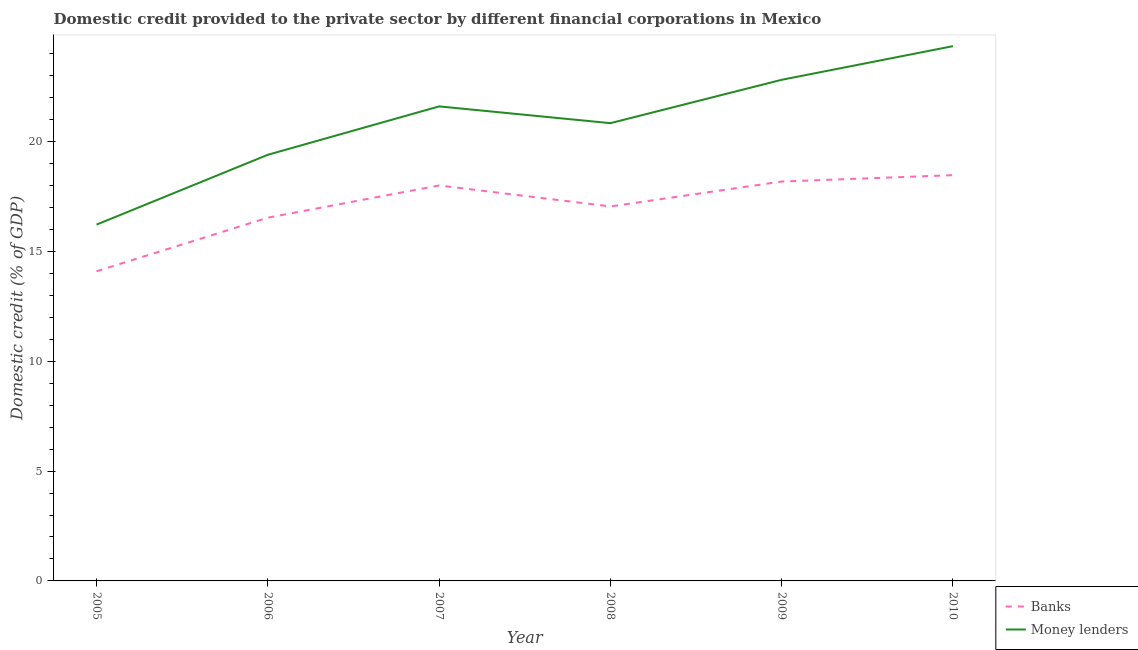Is the number of lines equal to the number of legend labels?
Keep it short and to the point. Yes. What is the domestic credit provided by money lenders in 2010?
Provide a short and direct response. 24.34. Across all years, what is the maximum domestic credit provided by money lenders?
Provide a short and direct response. 24.34. Across all years, what is the minimum domestic credit provided by money lenders?
Your answer should be very brief. 16.22. What is the total domestic credit provided by banks in the graph?
Keep it short and to the point. 102.33. What is the difference between the domestic credit provided by money lenders in 2005 and that in 2007?
Provide a short and direct response. -5.38. What is the difference between the domestic credit provided by money lenders in 2009 and the domestic credit provided by banks in 2008?
Offer a terse response. 5.77. What is the average domestic credit provided by banks per year?
Your answer should be compact. 17.05. In the year 2005, what is the difference between the domestic credit provided by banks and domestic credit provided by money lenders?
Give a very brief answer. -2.12. What is the ratio of the domestic credit provided by banks in 2008 to that in 2009?
Give a very brief answer. 0.94. What is the difference between the highest and the second highest domestic credit provided by banks?
Offer a terse response. 0.29. What is the difference between the highest and the lowest domestic credit provided by money lenders?
Offer a very short reply. 8.12. Is the domestic credit provided by banks strictly less than the domestic credit provided by money lenders over the years?
Provide a short and direct response. Yes. How many lines are there?
Offer a very short reply. 2. How many years are there in the graph?
Give a very brief answer. 6. Does the graph contain grids?
Provide a short and direct response. No. Where does the legend appear in the graph?
Keep it short and to the point. Bottom right. How are the legend labels stacked?
Provide a succinct answer. Vertical. What is the title of the graph?
Provide a succinct answer. Domestic credit provided to the private sector by different financial corporations in Mexico. Does "US$" appear as one of the legend labels in the graph?
Provide a succinct answer. No. What is the label or title of the Y-axis?
Ensure brevity in your answer.  Domestic credit (% of GDP). What is the Domestic credit (% of GDP) of Banks in 2005?
Your answer should be very brief. 14.1. What is the Domestic credit (% of GDP) in Money lenders in 2005?
Offer a terse response. 16.22. What is the Domestic credit (% of GDP) in Banks in 2006?
Give a very brief answer. 16.54. What is the Domestic credit (% of GDP) of Money lenders in 2006?
Make the answer very short. 19.4. What is the Domestic credit (% of GDP) in Banks in 2007?
Your response must be concise. 18. What is the Domestic credit (% of GDP) in Money lenders in 2007?
Offer a terse response. 21.6. What is the Domestic credit (% of GDP) of Banks in 2008?
Keep it short and to the point. 17.05. What is the Domestic credit (% of GDP) of Money lenders in 2008?
Your answer should be compact. 20.84. What is the Domestic credit (% of GDP) in Banks in 2009?
Make the answer very short. 18.18. What is the Domestic credit (% of GDP) of Money lenders in 2009?
Offer a terse response. 22.81. What is the Domestic credit (% of GDP) of Banks in 2010?
Give a very brief answer. 18.47. What is the Domestic credit (% of GDP) of Money lenders in 2010?
Give a very brief answer. 24.34. Across all years, what is the maximum Domestic credit (% of GDP) of Banks?
Provide a succinct answer. 18.47. Across all years, what is the maximum Domestic credit (% of GDP) of Money lenders?
Offer a terse response. 24.34. Across all years, what is the minimum Domestic credit (% of GDP) of Banks?
Your answer should be very brief. 14.1. Across all years, what is the minimum Domestic credit (% of GDP) of Money lenders?
Your response must be concise. 16.22. What is the total Domestic credit (% of GDP) in Banks in the graph?
Ensure brevity in your answer.  102.33. What is the total Domestic credit (% of GDP) in Money lenders in the graph?
Provide a succinct answer. 125.21. What is the difference between the Domestic credit (% of GDP) in Banks in 2005 and that in 2006?
Your answer should be very brief. -2.44. What is the difference between the Domestic credit (% of GDP) in Money lenders in 2005 and that in 2006?
Keep it short and to the point. -3.18. What is the difference between the Domestic credit (% of GDP) of Banks in 2005 and that in 2007?
Your response must be concise. -3.91. What is the difference between the Domestic credit (% of GDP) of Money lenders in 2005 and that in 2007?
Your answer should be compact. -5.38. What is the difference between the Domestic credit (% of GDP) in Banks in 2005 and that in 2008?
Offer a very short reply. -2.95. What is the difference between the Domestic credit (% of GDP) in Money lenders in 2005 and that in 2008?
Provide a succinct answer. -4.62. What is the difference between the Domestic credit (% of GDP) in Banks in 2005 and that in 2009?
Ensure brevity in your answer.  -4.08. What is the difference between the Domestic credit (% of GDP) in Money lenders in 2005 and that in 2009?
Your answer should be compact. -6.59. What is the difference between the Domestic credit (% of GDP) of Banks in 2005 and that in 2010?
Offer a terse response. -4.38. What is the difference between the Domestic credit (% of GDP) of Money lenders in 2005 and that in 2010?
Provide a succinct answer. -8.12. What is the difference between the Domestic credit (% of GDP) of Banks in 2006 and that in 2007?
Offer a terse response. -1.47. What is the difference between the Domestic credit (% of GDP) in Money lenders in 2006 and that in 2007?
Ensure brevity in your answer.  -2.2. What is the difference between the Domestic credit (% of GDP) in Banks in 2006 and that in 2008?
Keep it short and to the point. -0.51. What is the difference between the Domestic credit (% of GDP) in Money lenders in 2006 and that in 2008?
Make the answer very short. -1.44. What is the difference between the Domestic credit (% of GDP) in Banks in 2006 and that in 2009?
Offer a very short reply. -1.64. What is the difference between the Domestic credit (% of GDP) in Money lenders in 2006 and that in 2009?
Your answer should be compact. -3.41. What is the difference between the Domestic credit (% of GDP) of Banks in 2006 and that in 2010?
Provide a short and direct response. -1.93. What is the difference between the Domestic credit (% of GDP) of Money lenders in 2006 and that in 2010?
Give a very brief answer. -4.95. What is the difference between the Domestic credit (% of GDP) in Banks in 2007 and that in 2008?
Make the answer very short. 0.96. What is the difference between the Domestic credit (% of GDP) of Money lenders in 2007 and that in 2008?
Ensure brevity in your answer.  0.76. What is the difference between the Domestic credit (% of GDP) of Banks in 2007 and that in 2009?
Make the answer very short. -0.18. What is the difference between the Domestic credit (% of GDP) of Money lenders in 2007 and that in 2009?
Offer a very short reply. -1.21. What is the difference between the Domestic credit (% of GDP) of Banks in 2007 and that in 2010?
Provide a short and direct response. -0.47. What is the difference between the Domestic credit (% of GDP) of Money lenders in 2007 and that in 2010?
Offer a terse response. -2.74. What is the difference between the Domestic credit (% of GDP) in Banks in 2008 and that in 2009?
Keep it short and to the point. -1.13. What is the difference between the Domestic credit (% of GDP) in Money lenders in 2008 and that in 2009?
Your answer should be compact. -1.97. What is the difference between the Domestic credit (% of GDP) of Banks in 2008 and that in 2010?
Provide a succinct answer. -1.42. What is the difference between the Domestic credit (% of GDP) of Money lenders in 2008 and that in 2010?
Make the answer very short. -3.51. What is the difference between the Domestic credit (% of GDP) of Banks in 2009 and that in 2010?
Your answer should be very brief. -0.29. What is the difference between the Domestic credit (% of GDP) in Money lenders in 2009 and that in 2010?
Keep it short and to the point. -1.53. What is the difference between the Domestic credit (% of GDP) of Banks in 2005 and the Domestic credit (% of GDP) of Money lenders in 2006?
Provide a short and direct response. -5.3. What is the difference between the Domestic credit (% of GDP) in Banks in 2005 and the Domestic credit (% of GDP) in Money lenders in 2007?
Offer a very short reply. -7.5. What is the difference between the Domestic credit (% of GDP) in Banks in 2005 and the Domestic credit (% of GDP) in Money lenders in 2008?
Your response must be concise. -6.74. What is the difference between the Domestic credit (% of GDP) in Banks in 2005 and the Domestic credit (% of GDP) in Money lenders in 2009?
Make the answer very short. -8.72. What is the difference between the Domestic credit (% of GDP) of Banks in 2005 and the Domestic credit (% of GDP) of Money lenders in 2010?
Offer a very short reply. -10.25. What is the difference between the Domestic credit (% of GDP) of Banks in 2006 and the Domestic credit (% of GDP) of Money lenders in 2007?
Make the answer very short. -5.06. What is the difference between the Domestic credit (% of GDP) of Banks in 2006 and the Domestic credit (% of GDP) of Money lenders in 2008?
Ensure brevity in your answer.  -4.3. What is the difference between the Domestic credit (% of GDP) of Banks in 2006 and the Domestic credit (% of GDP) of Money lenders in 2009?
Keep it short and to the point. -6.28. What is the difference between the Domestic credit (% of GDP) of Banks in 2006 and the Domestic credit (% of GDP) of Money lenders in 2010?
Give a very brief answer. -7.81. What is the difference between the Domestic credit (% of GDP) of Banks in 2007 and the Domestic credit (% of GDP) of Money lenders in 2008?
Make the answer very short. -2.83. What is the difference between the Domestic credit (% of GDP) of Banks in 2007 and the Domestic credit (% of GDP) of Money lenders in 2009?
Offer a very short reply. -4.81. What is the difference between the Domestic credit (% of GDP) in Banks in 2007 and the Domestic credit (% of GDP) in Money lenders in 2010?
Ensure brevity in your answer.  -6.34. What is the difference between the Domestic credit (% of GDP) in Banks in 2008 and the Domestic credit (% of GDP) in Money lenders in 2009?
Your answer should be very brief. -5.77. What is the difference between the Domestic credit (% of GDP) in Banks in 2008 and the Domestic credit (% of GDP) in Money lenders in 2010?
Provide a short and direct response. -7.3. What is the difference between the Domestic credit (% of GDP) of Banks in 2009 and the Domestic credit (% of GDP) of Money lenders in 2010?
Provide a short and direct response. -6.16. What is the average Domestic credit (% of GDP) in Banks per year?
Offer a terse response. 17.05. What is the average Domestic credit (% of GDP) in Money lenders per year?
Offer a terse response. 20.87. In the year 2005, what is the difference between the Domestic credit (% of GDP) of Banks and Domestic credit (% of GDP) of Money lenders?
Ensure brevity in your answer.  -2.12. In the year 2006, what is the difference between the Domestic credit (% of GDP) in Banks and Domestic credit (% of GDP) in Money lenders?
Your answer should be compact. -2.86. In the year 2007, what is the difference between the Domestic credit (% of GDP) in Banks and Domestic credit (% of GDP) in Money lenders?
Ensure brevity in your answer.  -3.6. In the year 2008, what is the difference between the Domestic credit (% of GDP) of Banks and Domestic credit (% of GDP) of Money lenders?
Give a very brief answer. -3.79. In the year 2009, what is the difference between the Domestic credit (% of GDP) of Banks and Domestic credit (% of GDP) of Money lenders?
Your response must be concise. -4.63. In the year 2010, what is the difference between the Domestic credit (% of GDP) of Banks and Domestic credit (% of GDP) of Money lenders?
Your response must be concise. -5.87. What is the ratio of the Domestic credit (% of GDP) of Banks in 2005 to that in 2006?
Give a very brief answer. 0.85. What is the ratio of the Domestic credit (% of GDP) in Money lenders in 2005 to that in 2006?
Your answer should be very brief. 0.84. What is the ratio of the Domestic credit (% of GDP) of Banks in 2005 to that in 2007?
Keep it short and to the point. 0.78. What is the ratio of the Domestic credit (% of GDP) in Money lenders in 2005 to that in 2007?
Provide a short and direct response. 0.75. What is the ratio of the Domestic credit (% of GDP) in Banks in 2005 to that in 2008?
Your answer should be very brief. 0.83. What is the ratio of the Domestic credit (% of GDP) of Money lenders in 2005 to that in 2008?
Keep it short and to the point. 0.78. What is the ratio of the Domestic credit (% of GDP) in Banks in 2005 to that in 2009?
Your answer should be compact. 0.78. What is the ratio of the Domestic credit (% of GDP) in Money lenders in 2005 to that in 2009?
Ensure brevity in your answer.  0.71. What is the ratio of the Domestic credit (% of GDP) in Banks in 2005 to that in 2010?
Ensure brevity in your answer.  0.76. What is the ratio of the Domestic credit (% of GDP) of Money lenders in 2005 to that in 2010?
Your response must be concise. 0.67. What is the ratio of the Domestic credit (% of GDP) in Banks in 2006 to that in 2007?
Your response must be concise. 0.92. What is the ratio of the Domestic credit (% of GDP) of Money lenders in 2006 to that in 2007?
Make the answer very short. 0.9. What is the ratio of the Domestic credit (% of GDP) of Banks in 2006 to that in 2008?
Ensure brevity in your answer.  0.97. What is the ratio of the Domestic credit (% of GDP) in Money lenders in 2006 to that in 2008?
Offer a terse response. 0.93. What is the ratio of the Domestic credit (% of GDP) of Banks in 2006 to that in 2009?
Provide a succinct answer. 0.91. What is the ratio of the Domestic credit (% of GDP) of Money lenders in 2006 to that in 2009?
Keep it short and to the point. 0.85. What is the ratio of the Domestic credit (% of GDP) of Banks in 2006 to that in 2010?
Make the answer very short. 0.9. What is the ratio of the Domestic credit (% of GDP) in Money lenders in 2006 to that in 2010?
Offer a very short reply. 0.8. What is the ratio of the Domestic credit (% of GDP) of Banks in 2007 to that in 2008?
Keep it short and to the point. 1.06. What is the ratio of the Domestic credit (% of GDP) in Money lenders in 2007 to that in 2008?
Make the answer very short. 1.04. What is the ratio of the Domestic credit (% of GDP) of Banks in 2007 to that in 2009?
Your response must be concise. 0.99. What is the ratio of the Domestic credit (% of GDP) of Money lenders in 2007 to that in 2009?
Keep it short and to the point. 0.95. What is the ratio of the Domestic credit (% of GDP) in Banks in 2007 to that in 2010?
Offer a terse response. 0.97. What is the ratio of the Domestic credit (% of GDP) in Money lenders in 2007 to that in 2010?
Keep it short and to the point. 0.89. What is the ratio of the Domestic credit (% of GDP) of Banks in 2008 to that in 2009?
Your answer should be compact. 0.94. What is the ratio of the Domestic credit (% of GDP) in Money lenders in 2008 to that in 2009?
Provide a succinct answer. 0.91. What is the ratio of the Domestic credit (% of GDP) of Banks in 2008 to that in 2010?
Your response must be concise. 0.92. What is the ratio of the Domestic credit (% of GDP) in Money lenders in 2008 to that in 2010?
Offer a terse response. 0.86. What is the ratio of the Domestic credit (% of GDP) of Banks in 2009 to that in 2010?
Keep it short and to the point. 0.98. What is the ratio of the Domestic credit (% of GDP) of Money lenders in 2009 to that in 2010?
Offer a terse response. 0.94. What is the difference between the highest and the second highest Domestic credit (% of GDP) in Banks?
Keep it short and to the point. 0.29. What is the difference between the highest and the second highest Domestic credit (% of GDP) in Money lenders?
Keep it short and to the point. 1.53. What is the difference between the highest and the lowest Domestic credit (% of GDP) in Banks?
Give a very brief answer. 4.38. What is the difference between the highest and the lowest Domestic credit (% of GDP) in Money lenders?
Keep it short and to the point. 8.12. 